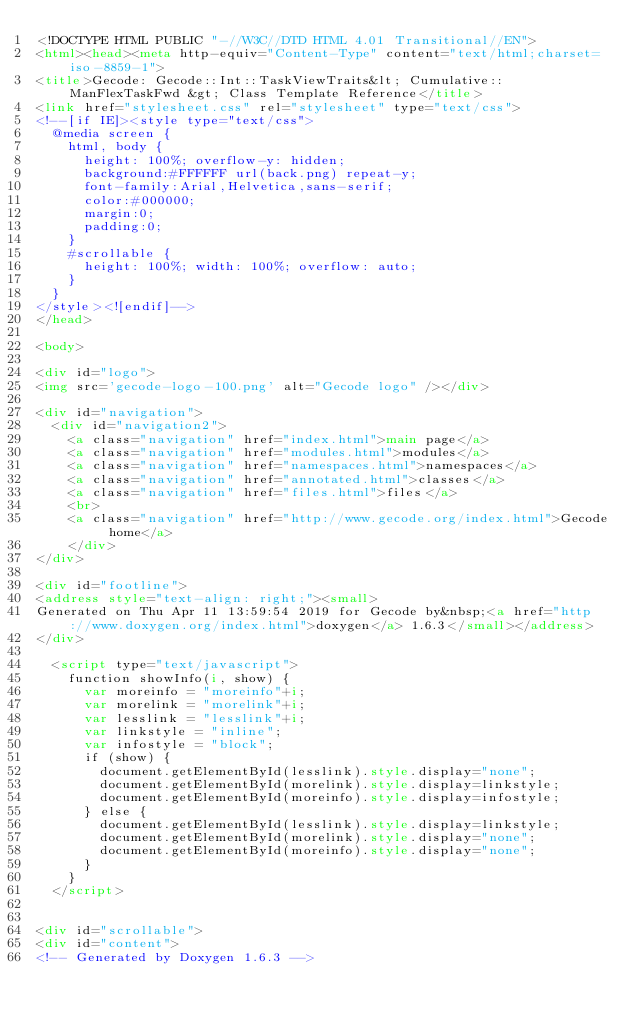<code> <loc_0><loc_0><loc_500><loc_500><_HTML_><!DOCTYPE HTML PUBLIC "-//W3C//DTD HTML 4.01 Transitional//EN">
<html><head><meta http-equiv="Content-Type" content="text/html;charset=iso-8859-1">
<title>Gecode: Gecode::Int::TaskViewTraits&lt; Cumulative::ManFlexTaskFwd &gt; Class Template Reference</title>
<link href="stylesheet.css" rel="stylesheet" type="text/css">
<!--[if IE]><style type="text/css">
  @media screen {
    html, body {
      height: 100%; overflow-y: hidden;
      background:#FFFFFF url(back.png) repeat-y;
      font-family:Arial,Helvetica,sans-serif;
      color:#000000;
      margin:0;
      padding:0;
    }
    #scrollable {
      height: 100%; width: 100%; overflow: auto;
    }
  }
</style><![endif]-->
</head>

<body>

<div id="logo">
<img src='gecode-logo-100.png' alt="Gecode logo" /></div>

<div id="navigation">
  <div id="navigation2">
    <a class="navigation" href="index.html">main page</a>
    <a class="navigation" href="modules.html">modules</a>
    <a class="navigation" href="namespaces.html">namespaces</a>
    <a class="navigation" href="annotated.html">classes</a>
    <a class="navigation" href="files.html">files</a>
    <br>
    <a class="navigation" href="http://www.gecode.org/index.html">Gecode home</a>
    </div>
</div>

<div id="footline">
<address style="text-align: right;"><small>
Generated on Thu Apr 11 13:59:54 2019 for Gecode by&nbsp;<a href="http://www.doxygen.org/index.html">doxygen</a> 1.6.3</small></address>
</div>

  <script type="text/javascript">
    function showInfo(i, show) {
      var moreinfo = "moreinfo"+i;
      var morelink = "morelink"+i;
      var lesslink = "lesslink"+i;
      var linkstyle = "inline";
      var infostyle = "block";
      if (show) {
        document.getElementById(lesslink).style.display="none";
        document.getElementById(morelink).style.display=linkstyle;
        document.getElementById(moreinfo).style.display=infostyle;
      } else {
        document.getElementById(lesslink).style.display=linkstyle;
        document.getElementById(morelink).style.display="none";
        document.getElementById(moreinfo).style.display="none";
      }
    }
  </script>


<div id="scrollable">
<div id="content">
<!-- Generated by Doxygen 1.6.3 --></code> 